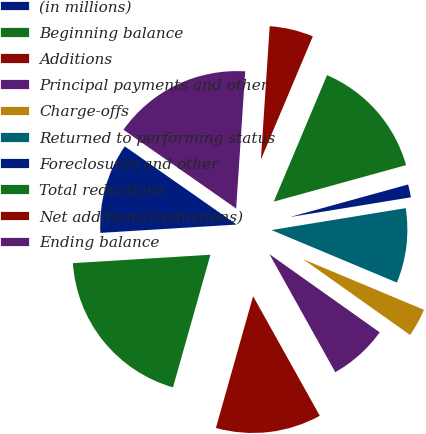Convert chart to OTSL. <chart><loc_0><loc_0><loc_500><loc_500><pie_chart><fcel>(in millions)<fcel>Beginning balance<fcel>Additions<fcel>Principal payments and other<fcel>Charge-offs<fcel>Returned to performing status<fcel>Foreclosures and other<fcel>Total reductions<fcel>Net additions/(reductions)<fcel>Ending balance<nl><fcel>10.68%<fcel>19.65%<fcel>12.48%<fcel>7.09%<fcel>3.5%<fcel>8.89%<fcel>1.71%<fcel>14.37%<fcel>5.3%<fcel>16.34%<nl></chart> 